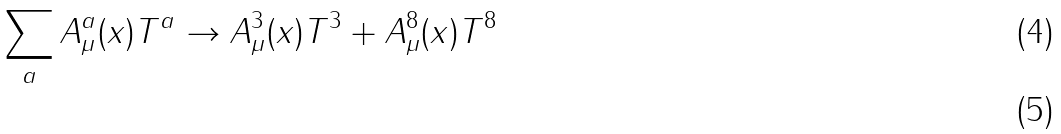<formula> <loc_0><loc_0><loc_500><loc_500>\sum _ { a } A ^ { a } _ { \mu } ( x ) T ^ { a } \to A ^ { 3 } _ { \mu } ( x ) T ^ { 3 } + A ^ { 8 } _ { \mu } ( x ) T ^ { 8 } \\</formula> 